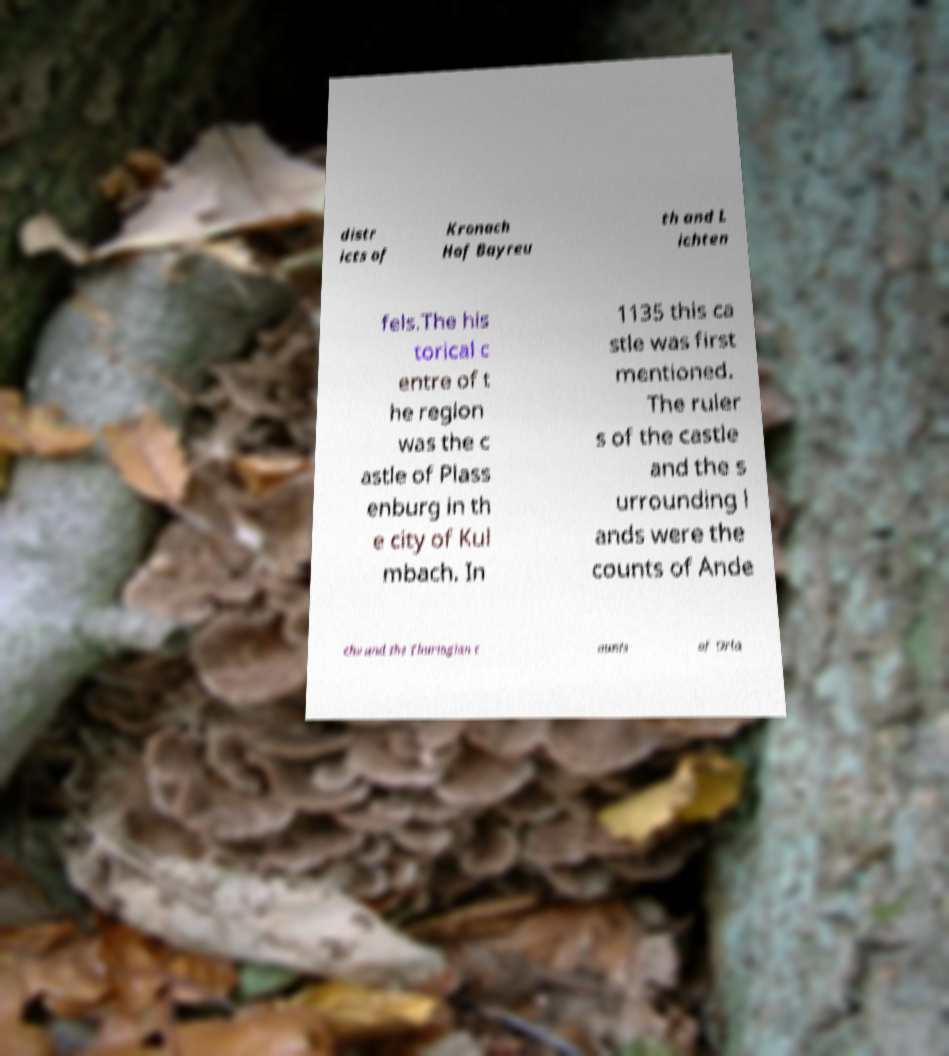Please identify and transcribe the text found in this image. distr icts of Kronach Hof Bayreu th and L ichten fels.The his torical c entre of t he region was the c astle of Plass enburg in th e city of Kul mbach. In 1135 this ca stle was first mentioned. The ruler s of the castle and the s urrounding l ands were the counts of Ande chs and the Thuringian c ounts of Orla 